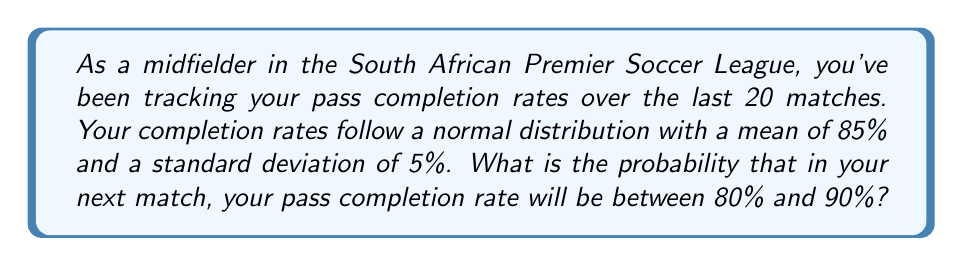Help me with this question. Let's approach this step-by-step:

1) We're dealing with a normal distribution where:
   Mean (μ) = 85%
   Standard deviation (σ) = 5%

2) We want to find the probability of the pass completion rate being between 80% and 90%.

3) To solve this, we need to calculate the z-scores for both 80% and 90%:

   For 80%: $z_1 = \frac{80 - 85}{5} = -1$
   For 90%: $z_2 = \frac{90 - 85}{5} = 1$

4) Now, we need to find the area under the standard normal curve between z = -1 and z = 1.

5) Using the standard normal distribution table or a calculator:
   P(Z ≤ 1) = 0.8413
   P(Z ≤ -1) = 0.1587

6) The probability we're looking for is the difference between these two:
   P(-1 ≤ Z ≤ 1) = 0.8413 - 0.1587 = 0.6826

7) Therefore, the probability that your pass completion rate will be between 80% and 90% in the next match is approximately 0.6826 or 68.26%.
Answer: 0.6826 or 68.26% 